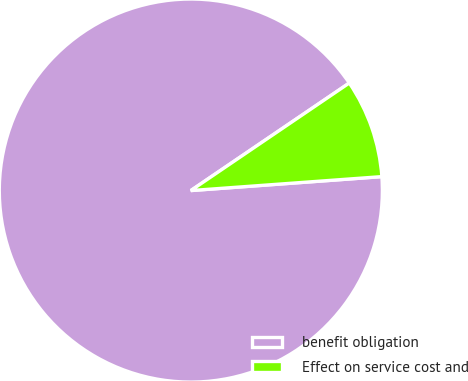Convert chart to OTSL. <chart><loc_0><loc_0><loc_500><loc_500><pie_chart><fcel>benefit obligation<fcel>Effect on service cost and<nl><fcel>91.67%<fcel>8.33%<nl></chart> 